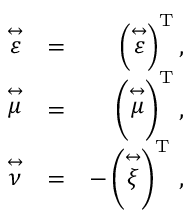Convert formula to latex. <formula><loc_0><loc_0><loc_500><loc_500>\begin{array} { r l r } { \stackrel { \leftrightarrow } { \varepsilon } } & { = } & { \left ( \stackrel { \leftrightarrow } { \varepsilon } \right ) ^ { T } , } \\ { \stackrel { \leftrightarrow } { \mu } } & { = } & { \left ( \stackrel { \leftrightarrow } { \mu } \right ) ^ { T } , } \\ { \stackrel { \leftrightarrow } { \nu } } & { = } & { - \left ( \stackrel { \leftrightarrow } { \xi } \right ) ^ { T } \, , } \end{array}</formula> 